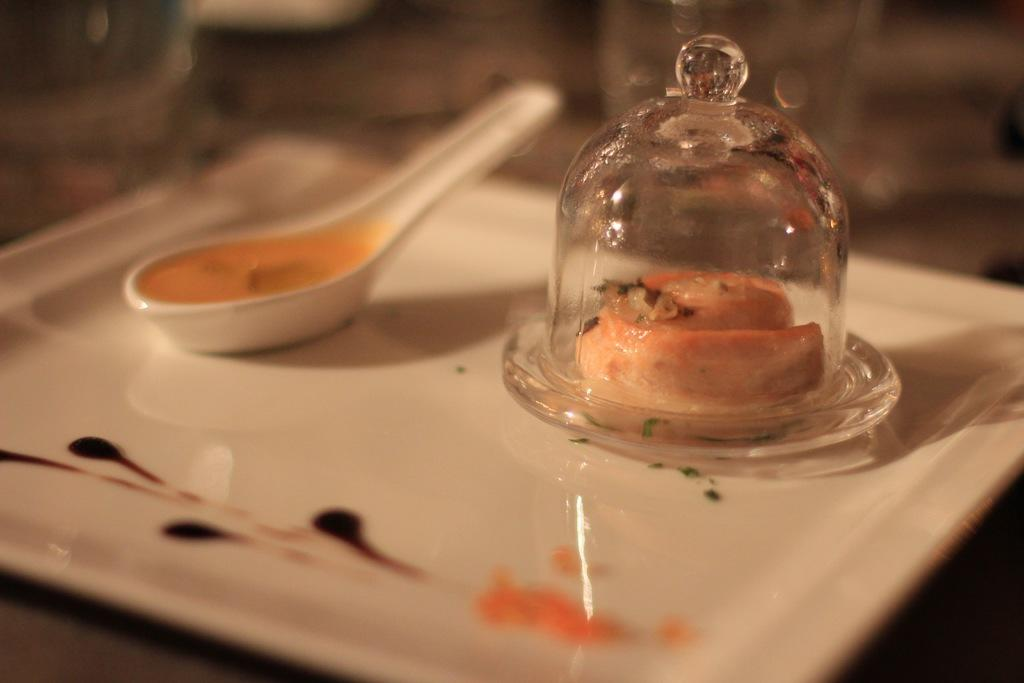What is in the soup spoon in the image? There are food items in the soup spoon. What is in the glass lid in the image? There are food items in a glass lid. Where are the soup spoon and the glass lid located? Both the soup spoon and the glass lid are on a plate. Can you describe the background of the image? The background of the image is blurred. How many ladybugs can be seen crawling on the plate in the image? There are no ladybugs present in the image; it only features food items in a soup spoon and a glass lid on a plate. 